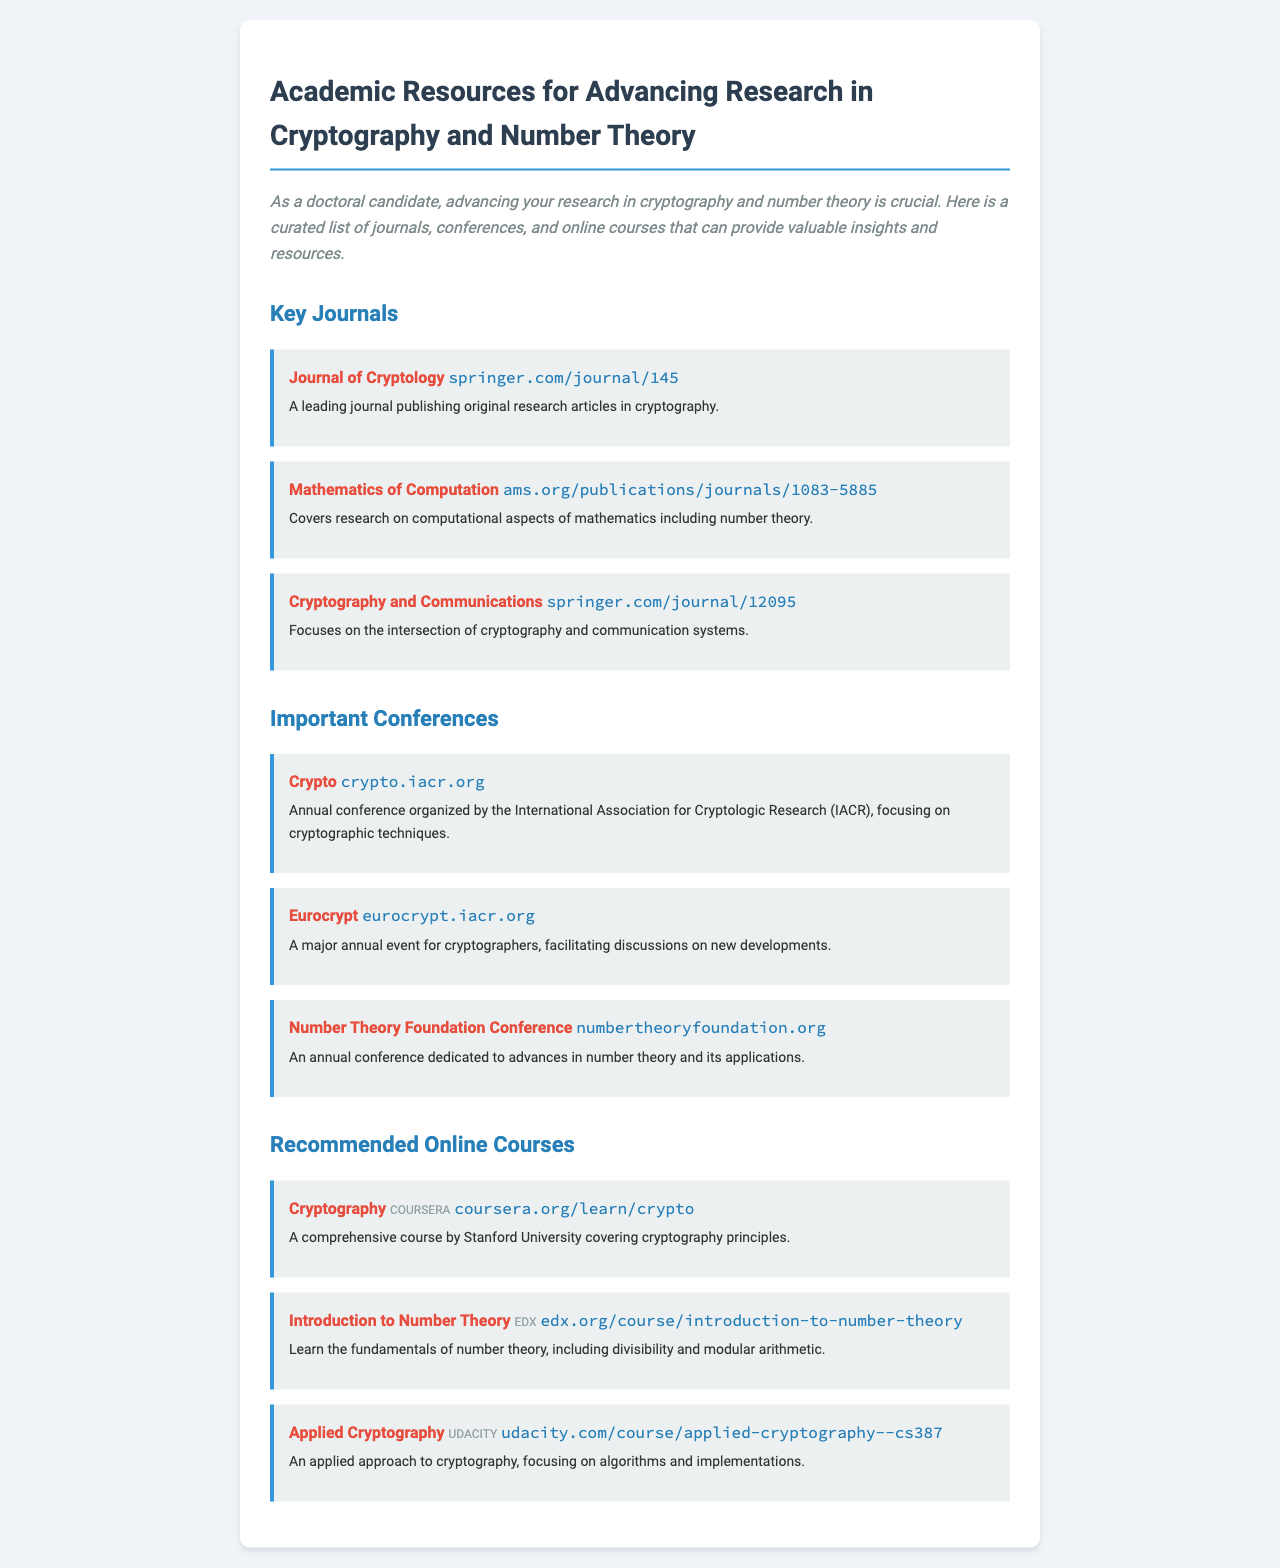what is the title of the newsletter? The title of the newsletter is prominently displayed at the top and states the subject of the content, which is focused on academic resources for cryptography and number theory.
Answer: Academic Resources for Advancing Research in Cryptography and Number Theory how many key journals are listed? The number of key journals can be determined by counting the entries in the "Key Journals" section of the document.
Answer: 3 which platform offers the course on Cryptography? The platform for the course on Cryptography is specified within the course listing and indicates where the course can be taken.
Answer: Coursera what is the focus of the Eurocrypt conference? The focus of the Eurocrypt conference is mentioned in its description, detailing its relevance and main activities regarding the subject matter.
Answer: New developments in cryptography name one online course that covers number theory. The online courses listed include different topics; one specifically addresses the fundamental concepts of number theory.
Answer: Introduction to Number Theory where is the Journal of Cryptology published? The publisher of the Journal of Cryptology can be found by looking at the resource information provided for the journal.
Answer: springer.com/journal/145 what is the main theme of the Number Theory Foundation Conference? The theme or focus of the Number Theory Foundation Conference is outlined in its description within the document.
Answer: Advances in number theory and its applications which course focuses on the practical application of cryptography? The course that emphasizes applied methods in cryptography is noted in the list of recommended online courses and its content description.
Answer: Applied Cryptography 